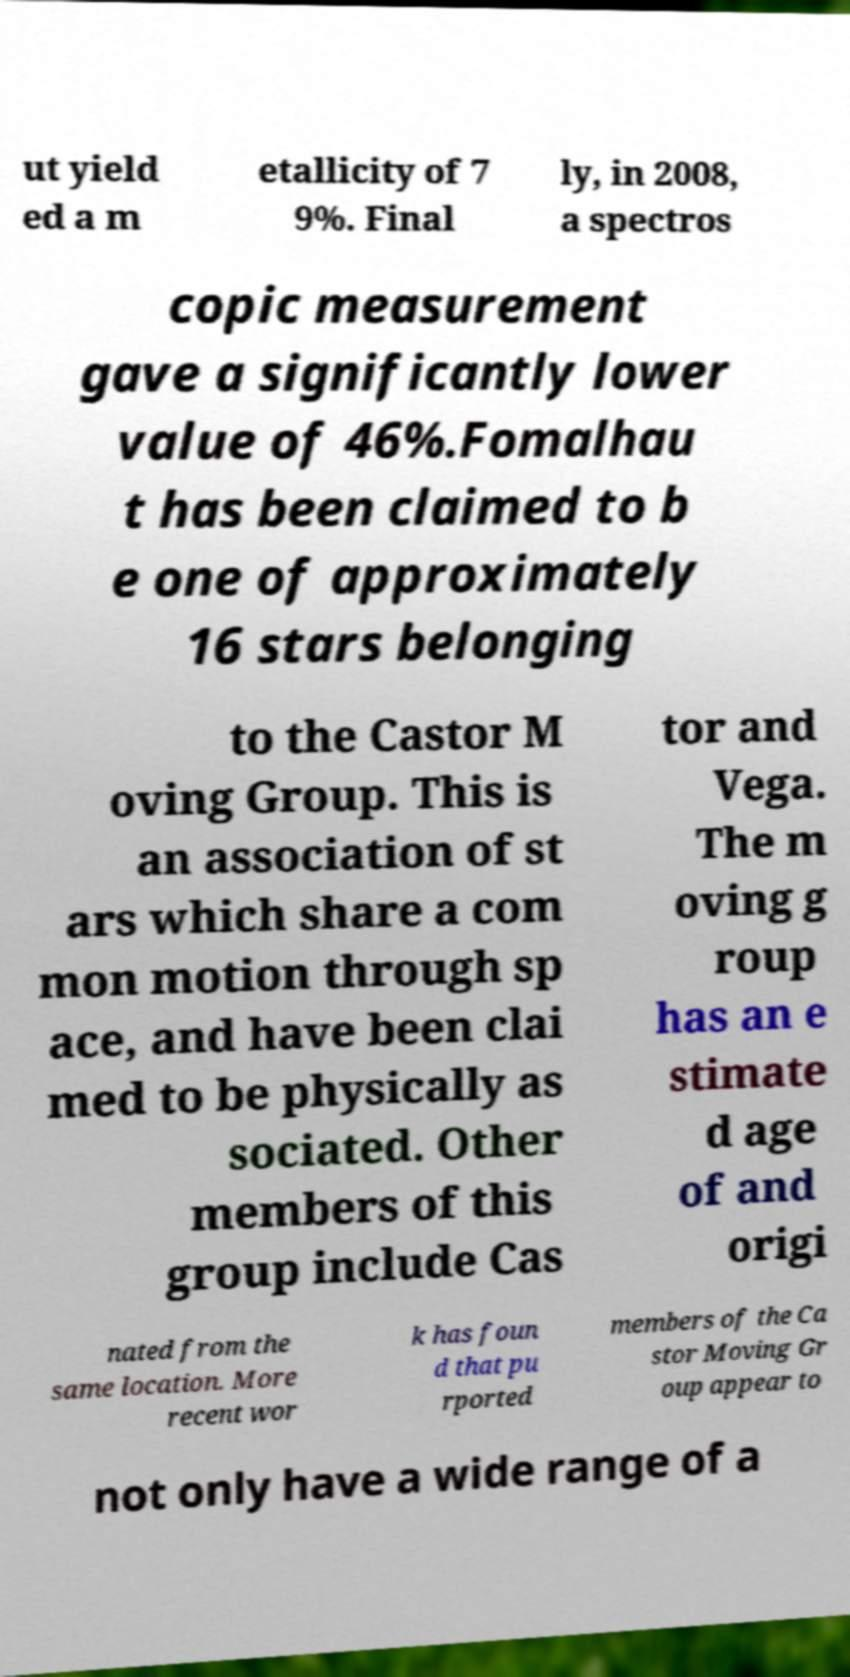Can you accurately transcribe the text from the provided image for me? ut yield ed a m etallicity of 7 9%. Final ly, in 2008, a spectros copic measurement gave a significantly lower value of 46%.Fomalhau t has been claimed to b e one of approximately 16 stars belonging to the Castor M oving Group. This is an association of st ars which share a com mon motion through sp ace, and have been clai med to be physically as sociated. Other members of this group include Cas tor and Vega. The m oving g roup has an e stimate d age of and origi nated from the same location. More recent wor k has foun d that pu rported members of the Ca stor Moving Gr oup appear to not only have a wide range of a 